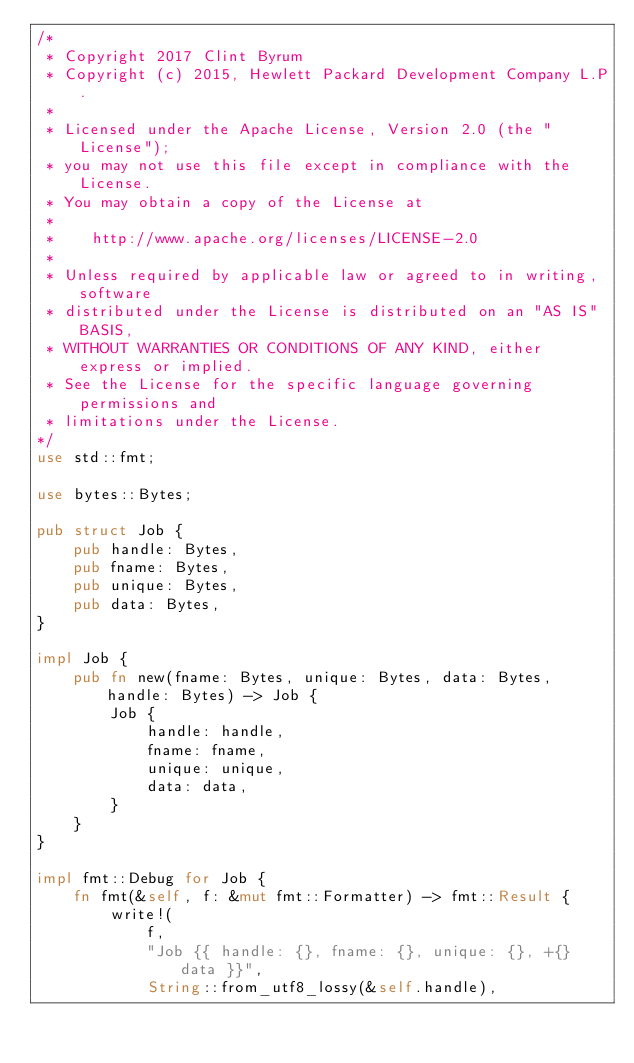<code> <loc_0><loc_0><loc_500><loc_500><_Rust_>/*
 * Copyright 2017 Clint Byrum
 * Copyright (c) 2015, Hewlett Packard Development Company L.P.
 *
 * Licensed under the Apache License, Version 2.0 (the "License");
 * you may not use this file except in compliance with the License.
 * You may obtain a copy of the License at
 *
 *    http://www.apache.org/licenses/LICENSE-2.0
 *
 * Unless required by applicable law or agreed to in writing, software
 * distributed under the License is distributed on an "AS IS" BASIS,
 * WITHOUT WARRANTIES OR CONDITIONS OF ANY KIND, either express or implied.
 * See the License for the specific language governing permissions and
 * limitations under the License.
*/
use std::fmt;

use bytes::Bytes;

pub struct Job {
    pub handle: Bytes,
    pub fname: Bytes,
    pub unique: Bytes,
    pub data: Bytes,
}

impl Job {
    pub fn new(fname: Bytes, unique: Bytes, data: Bytes, handle: Bytes) -> Job {
        Job {
            handle: handle,
            fname: fname,
            unique: unique,
            data: data,
        }
    }
}

impl fmt::Debug for Job {
    fn fmt(&self, f: &mut fmt::Formatter) -> fmt::Result {
        write!(
            f,
            "Job {{ handle: {}, fname: {}, unique: {}, +{} data }}",
            String::from_utf8_lossy(&self.handle),</code> 